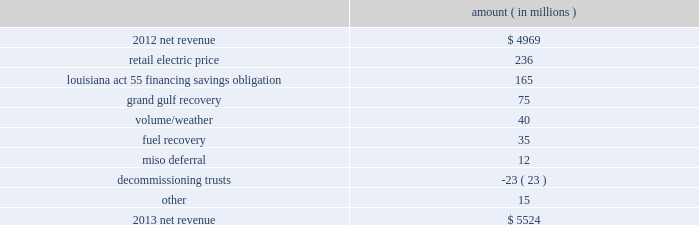Net revenue utility following is an analysis of the change in net revenue comparing 2013 to 2012 .
Amount ( in millions ) .
The retail electric price variance is primarily due to : 2022 a formula rate plan increase at entergy louisiana , effective january 2013 , which includes an increase relating to the waterford 3 steam generator replacement project , which was placed in service in december 2012 .
The net income effect of the formula rate plan increase is limited to a portion representing an allowed return on equity with the remainder offset by costs included in other operation and maintenance expenses , depreciation expenses , and taxes other than income taxes ; 2022 the recovery of hinds plant costs through the power management rider at entergy mississippi , as approved by the mpsc , effective with the first billing cycle of 2013 .
The net income effect of the hinds plant cost recovery is limited to a portion representing an allowed return on equity on the net plant investment with the remainder offset by the hinds plant costs in other operation and maintenance expenses , depreciation expenses , and taxes other than income taxes ; 2022 an increase in the capacity acquisition rider at entergy arkansas , as approved by the apsc , effective with the first billing cycle of december 2012 , relating to the hot spring plant acquisition .
The net income effect of the hot spring plant cost recovery is limited to a portion representing an allowed return on equity on the net plant investment with the remainder offset by the hot spring plant costs in other operation and maintenance expenses , depreciation expenses , and taxes other than income taxes ; 2022 increases in the energy efficiency rider , as approved by the apsc , effective july 2013 and july 2012 .
Energy efficiency revenues are offset by costs included in other operation and maintenance expenses and have no effect on net income ; 2022 an annual base rate increase at entergy texas , effective july 2012 , as a result of the puct 2019s order that was issued in september 2012 in the november 2011 rate case ; and 2022 a formula rate plan increase at entergy mississippi , effective september 2013 .
See note 2 to the financial statements for a discussion of rate proceedings .
The louisiana act 55 financing savings obligation variance results from a regulatory charge recorded in the second quarter 2012 because entergy gulf states louisiana and entergy louisiana agreed to share with customers the savings from an irs settlement related to the uncertain tax position regarding the hurricane katrina and hurricane rita louisiana act 55 financing .
See note 3 to the financial statements for additional discussion of the tax settlement .
Entergy corporation and subsidiaries management's financial discussion and analysis .
What percentage of the change in net revenue between 2012 and 2013 is due to volume/weather ? 
Computations: (40 / (5524 - 4969))
Answer: 0.07207. 